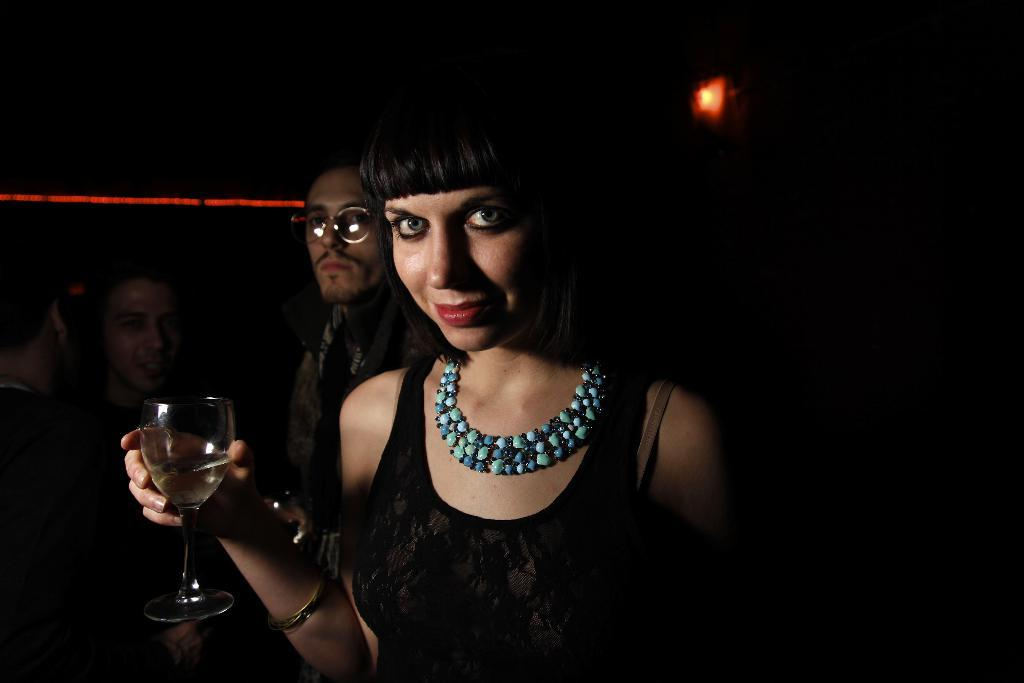Who is the main subject in the image? There is a woman in the image. What is the woman holding in the image? The woman is holding a wine glass. How many people are present in the image? There are three persons standing in the image. What is the color of the background in the image? The background of the image is dark. What type of border is visible around the woman in the image? There is no border visible around the woman in the image. What question is the woman asking in the image? The image does not show the woman asking a question. 